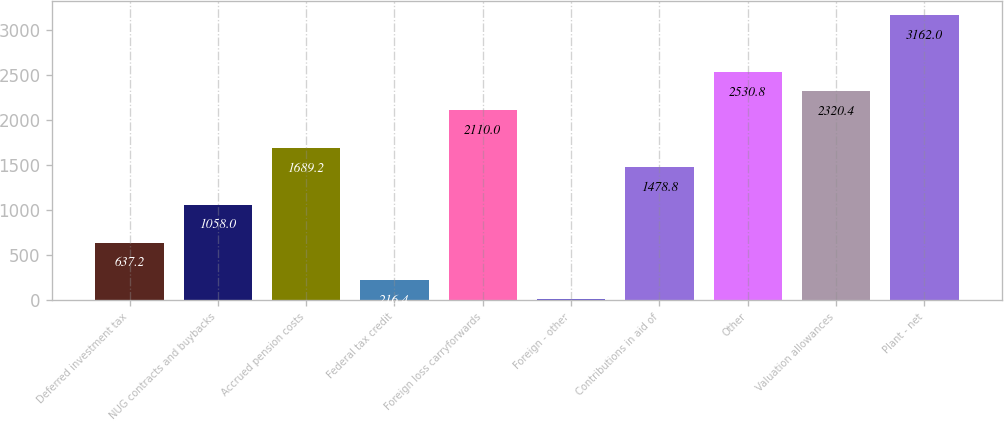Convert chart. <chart><loc_0><loc_0><loc_500><loc_500><bar_chart><fcel>Deferred investment tax<fcel>NUG contracts and buybacks<fcel>Accrued pension costs<fcel>Federal tax credit<fcel>Foreign loss carryforwards<fcel>Foreign - other<fcel>Contributions in aid of<fcel>Other<fcel>Valuation allowances<fcel>Plant - net<nl><fcel>637.2<fcel>1058<fcel>1689.2<fcel>216.4<fcel>2110<fcel>6<fcel>1478.8<fcel>2530.8<fcel>2320.4<fcel>3162<nl></chart> 